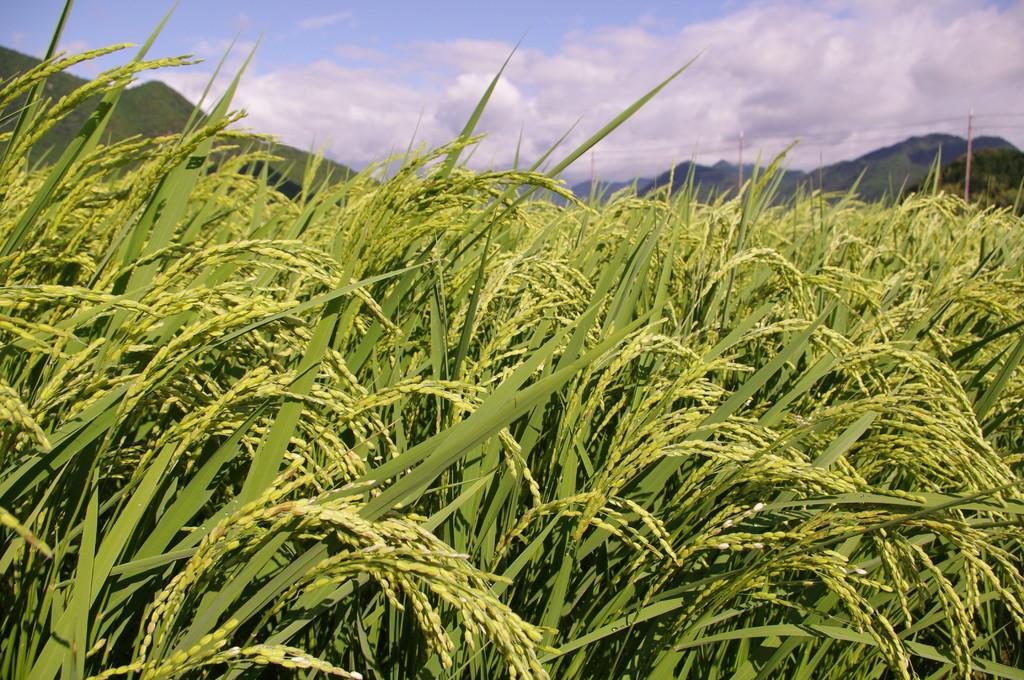What type of landscape is depicted in the image? There is a field in the image. What can be seen in the distance behind the field? There are mountains in the background of the image. What else is visible in the image besides the field and mountains? There are wires visible in the image. How would you describe the weather in the image? The sky is cloudy in the image. What time of day is it in the image, based on the hobbies of the people present? There are no people present in the image, so it is not possible to determine the time of day based on their hobbies. 